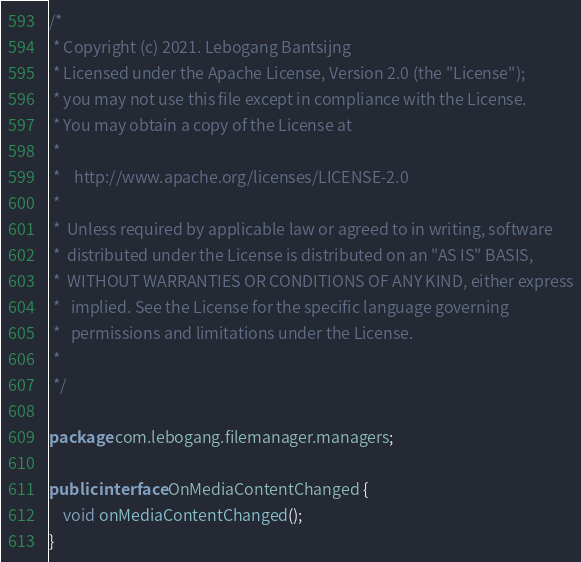<code> <loc_0><loc_0><loc_500><loc_500><_Java_>/*
 * Copyright (c) 2021. Lebogang Bantsijng
 * Licensed under the Apache License, Version 2.0 (the "License");
 * you may not use this file except in compliance with the License.
 * You may obtain a copy of the License at
 *
 *    http://www.apache.org/licenses/LICENSE-2.0
 *
 *  Unless required by applicable law or agreed to in writing, software
 *  distributed under the License is distributed on an "AS IS" BASIS,
 *  WITHOUT WARRANTIES OR CONDITIONS OF ANY KIND, either express
 *   implied. See the License for the specific language governing
 *   permissions and limitations under the License.
 *
 */

package com.lebogang.filemanager.managers;

public interface OnMediaContentChanged {
    void onMediaContentChanged();
}
</code> 